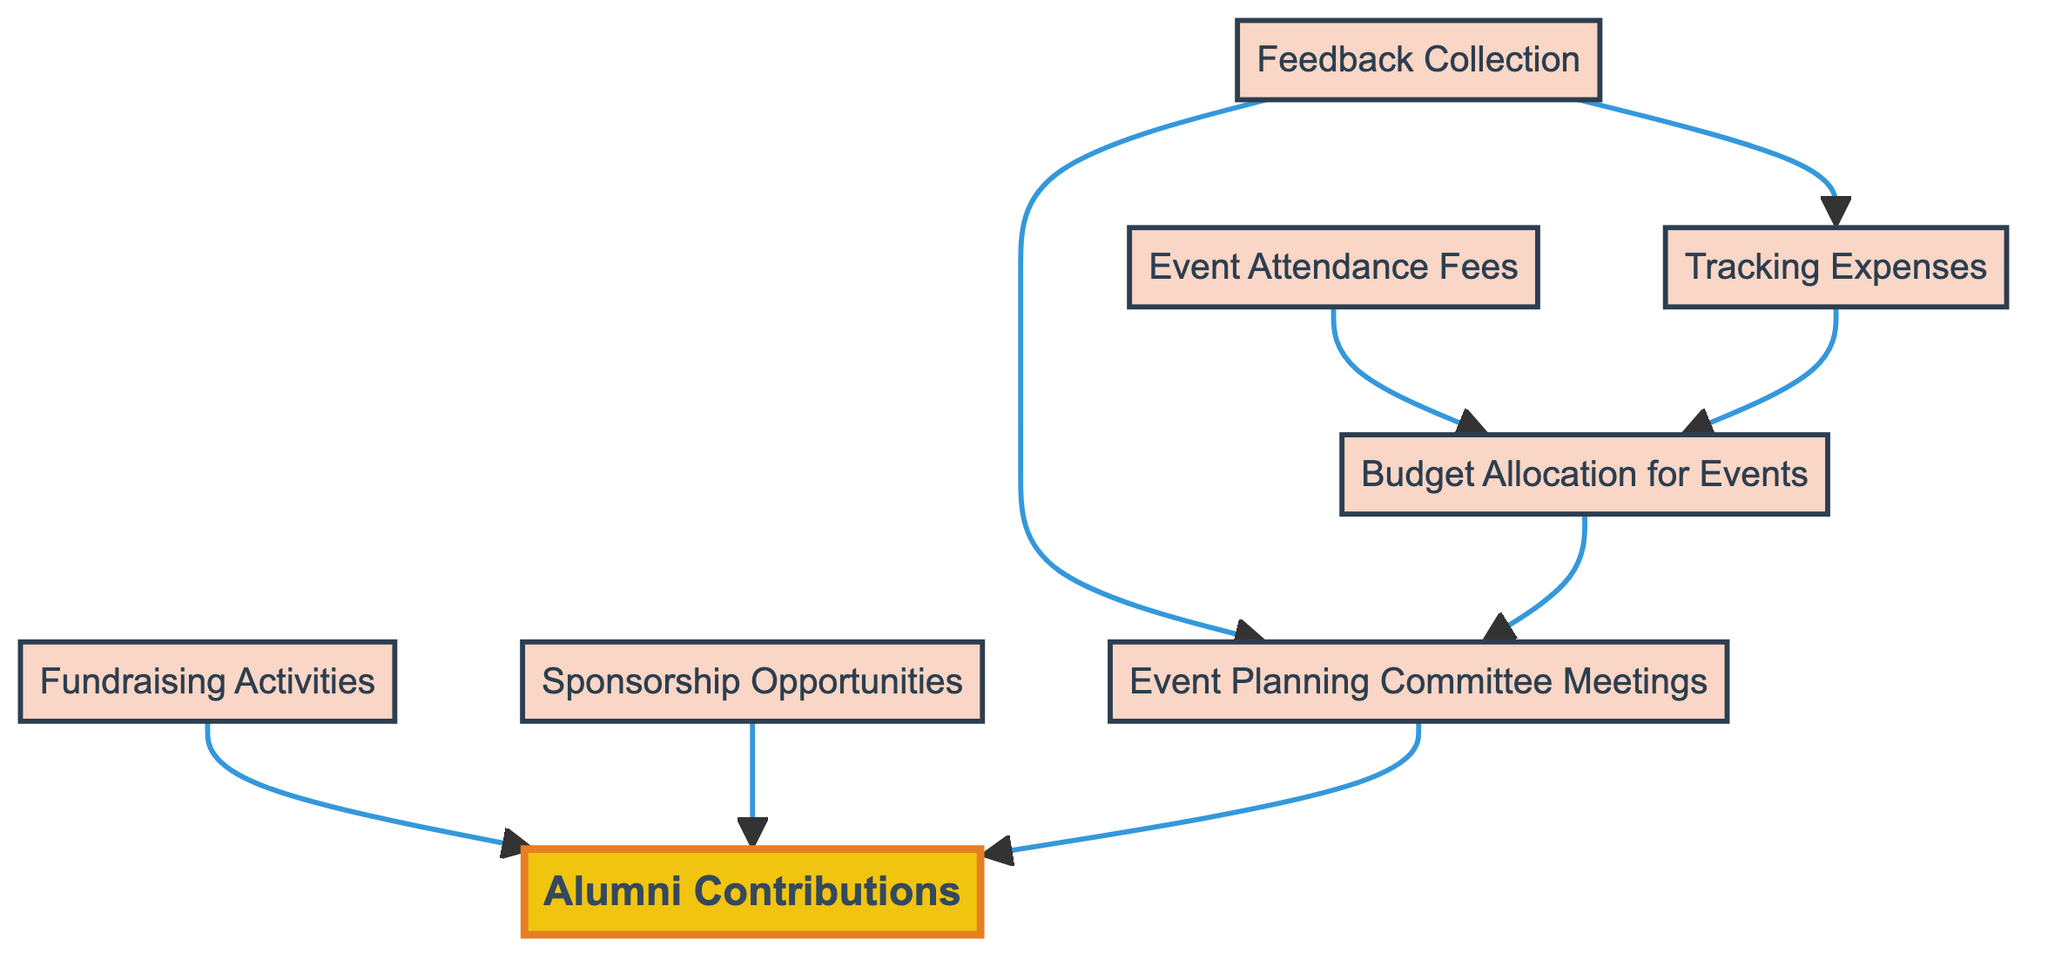What is the starting point of the budget flow? The starting point in the diagram is "Alumni Contributions" which indicates the source of funds for budgeting. This node leads into various budgeting activities and is essential for the flow to begin.
Answer: Alumni Contributions How many total nodes are present in the diagram? By counting all the unique elements, there are eight nodes represented in the diagram. These include "Alumni Contributions," "Event Planning Committee Meetings," "Budget Allocation for Events," "Sponsorship Opportunities," "Fundraising Activities," "Tracking Expenses," "Event Attendance Fees," and "Feedback Collection."
Answer: Eight Which node directly collects feedback? The "Feedback Collection" node is responsible for gathering feedback from alumni, as indicated by its description in the diagram. It is depicted as feeding into "Tracking Expenses" and "Event Planning Committee Meetings."
Answer: Feedback Collection What links "Tracking Expenses" and "Budget Allocation for Events"? "Tracking Expenses" sends information or results to "Budget Allocation for Events," suggesting that monitoring expenses feeds into budget-related decisions. This is a direct link shown in the diagram, implying that expenses tracked influence how the budget is allocated.
Answer: Budget Allocation for Events What is the relationship between "Fundraising Activities" and "Alumni Contributions"? "Fundraising Activities" is linked to "Alumni Contributions," indicating that income generated from these activities will contribute to the overall budget available from alumni. This shows a flow where fundraising directly supports the funds received from alumni members.
Answer: Alumni Contributions Which nodes are influenced by "Event Attendance Fees"? The "Event Attendance Fees" node directly influences "Budget Allocation for Events" in the diagram. This means that fees collected from participants help determine how the budget is allocated for different events.
Answer: Budget Allocation for Events How many edges are in the diagram? By examining the connections between the nodes, there are several directed edges which show how different elements are connected. The total count of edges (connections) is seven, indicating the relationships among the various nodes present in the budget flow diagram.
Answer: Seven What does "Sponsorship Opportunities" aim to achieve? The purpose of "Sponsorship Opportunities" is to identify local businesses that can sponsor alumni activities. This aims to bring additional funding into the budget from external sources. Its direct link indicates that it leads to increased contributions toward alumni events and activities.
Answer: Local businesses Which node follows up on the feedback collected from alumni? The node that follows up on feedback collected is "Event Planning Committee Meetings." This suggests that the feedback is used to improve future planning sessions for alumni events, indicating a loop of continuous improvement in budget planning.
Answer: Event Planning Committee Meetings 